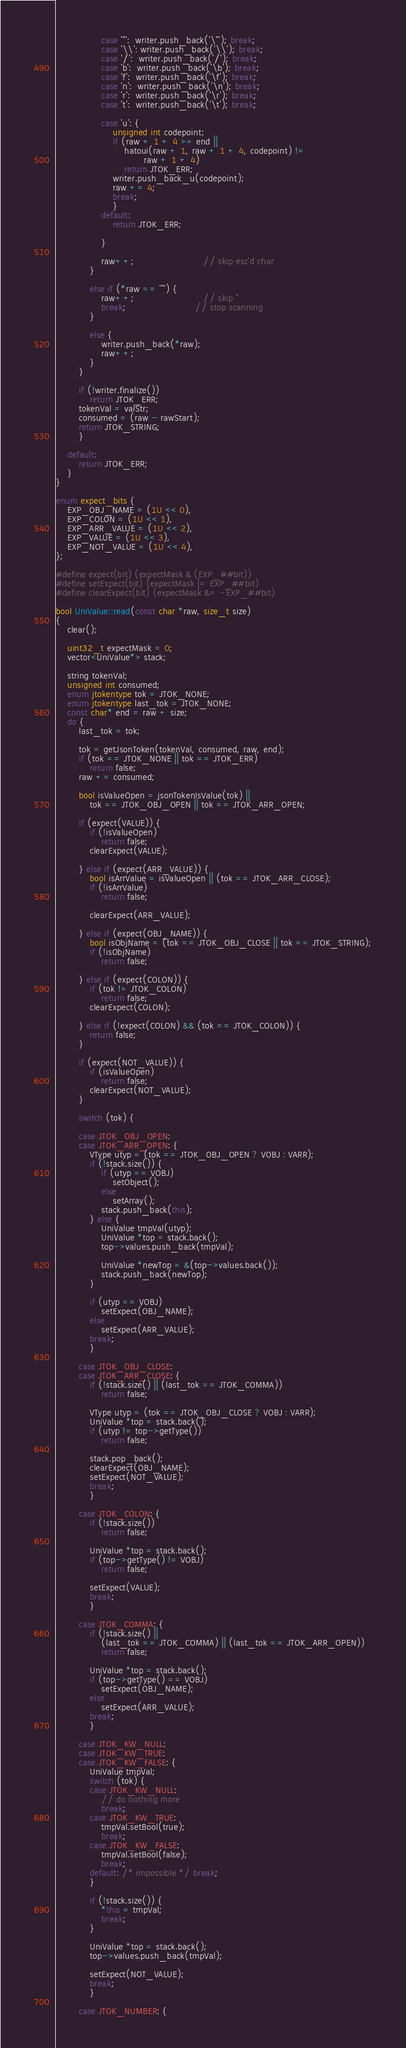<code> <loc_0><loc_0><loc_500><loc_500><_C++_>                case '"':  writer.push_back('\"'); break;
                case '\\': writer.push_back('\\'); break;
                case '/':  writer.push_back('/'); break;
                case 'b':  writer.push_back('\b'); break;
                case 'f':  writer.push_back('\f'); break;
                case 'n':  writer.push_back('\n'); break;
                case 'r':  writer.push_back('\r'); break;
                case 't':  writer.push_back('\t'); break;

                case 'u': {
                    unsigned int codepoint;
                    if (raw + 1 + 4 >= end ||
                        hatoui(raw + 1, raw + 1 + 4, codepoint) !=
                               raw + 1 + 4)
                        return JTOK_ERR;
                    writer.push_back_u(codepoint);
                    raw += 4;
                    break;
                    }
                default:
                    return JTOK_ERR;

                }

                raw++;                        // skip esc'd char
            }

            else if (*raw == '"') {
                raw++;                        // skip "
                break;                        // stop scanning
            }

            else {
                writer.push_back(*raw);
                raw++;
            }
        }

        if (!writer.finalize())
            return JTOK_ERR;
        tokenVal = valStr;
        consumed = (raw - rawStart);
        return JTOK_STRING;
        }

    default:
        return JTOK_ERR;
    }
}

enum expect_bits {
    EXP_OBJ_NAME = (1U << 0),
    EXP_COLON = (1U << 1),
    EXP_ARR_VALUE = (1U << 2),
    EXP_VALUE = (1U << 3),
    EXP_NOT_VALUE = (1U << 4),
};

#define expect(bit) (expectMask & (EXP_##bit))
#define setExpect(bit) (expectMask |= EXP_##bit)
#define clearExpect(bit) (expectMask &= ~EXP_##bit)

bool UniValue::read(const char *raw, size_t size)
{
    clear();

    uint32_t expectMask = 0;
    vector<UniValue*> stack;

    string tokenVal;
    unsigned int consumed;
    enum jtokentype tok = JTOK_NONE;
    enum jtokentype last_tok = JTOK_NONE;
    const char* end = raw + size;
    do {
        last_tok = tok;

        tok = getJsonToken(tokenVal, consumed, raw, end);
        if (tok == JTOK_NONE || tok == JTOK_ERR)
            return false;
        raw += consumed;

        bool isValueOpen = jsonTokenIsValue(tok) ||
            tok == JTOK_OBJ_OPEN || tok == JTOK_ARR_OPEN;

        if (expect(VALUE)) {
            if (!isValueOpen)
                return false;
            clearExpect(VALUE);

        } else if (expect(ARR_VALUE)) {
            bool isArrValue = isValueOpen || (tok == JTOK_ARR_CLOSE);
            if (!isArrValue)
                return false;

            clearExpect(ARR_VALUE);

        } else if (expect(OBJ_NAME)) {
            bool isObjName = (tok == JTOK_OBJ_CLOSE || tok == JTOK_STRING);
            if (!isObjName)
                return false;

        } else if (expect(COLON)) {
            if (tok != JTOK_COLON)
                return false;
            clearExpect(COLON);

        } else if (!expect(COLON) && (tok == JTOK_COLON)) {
            return false;
        }

        if (expect(NOT_VALUE)) {
            if (isValueOpen)
                return false;
            clearExpect(NOT_VALUE);
        }

        switch (tok) {

        case JTOK_OBJ_OPEN:
        case JTOK_ARR_OPEN: {
            VType utyp = (tok == JTOK_OBJ_OPEN ? VOBJ : VARR);
            if (!stack.size()) {
                if (utyp == VOBJ)
                    setObject();
                else
                    setArray();
                stack.push_back(this);
            } else {
                UniValue tmpVal(utyp);
                UniValue *top = stack.back();
                top->values.push_back(tmpVal);

                UniValue *newTop = &(top->values.back());
                stack.push_back(newTop);
            }

            if (utyp == VOBJ)
                setExpect(OBJ_NAME);
            else
                setExpect(ARR_VALUE);
            break;
            }

        case JTOK_OBJ_CLOSE:
        case JTOK_ARR_CLOSE: {
            if (!stack.size() || (last_tok == JTOK_COMMA))
                return false;

            VType utyp = (tok == JTOK_OBJ_CLOSE ? VOBJ : VARR);
            UniValue *top = stack.back();
            if (utyp != top->getType())
                return false;

            stack.pop_back();
            clearExpect(OBJ_NAME);
            setExpect(NOT_VALUE);
            break;
            }

        case JTOK_COLON: {
            if (!stack.size())
                return false;

            UniValue *top = stack.back();
            if (top->getType() != VOBJ)
                return false;

            setExpect(VALUE);
            break;
            }

        case JTOK_COMMA: {
            if (!stack.size() ||
                (last_tok == JTOK_COMMA) || (last_tok == JTOK_ARR_OPEN))
                return false;

            UniValue *top = stack.back();
            if (top->getType() == VOBJ)
                setExpect(OBJ_NAME);
            else
                setExpect(ARR_VALUE);
            break;
            }

        case JTOK_KW_NULL:
        case JTOK_KW_TRUE:
        case JTOK_KW_FALSE: {
            UniValue tmpVal;
            switch (tok) {
            case JTOK_KW_NULL:
                // do nothing more
                break;
            case JTOK_KW_TRUE:
                tmpVal.setBool(true);
                break;
            case JTOK_KW_FALSE:
                tmpVal.setBool(false);
                break;
            default: /* impossible */ break;
            }

            if (!stack.size()) {
                *this = tmpVal;
                break;
            }

            UniValue *top = stack.back();
            top->values.push_back(tmpVal);

            setExpect(NOT_VALUE);
            break;
            }

        case JTOK_NUMBER: {</code> 